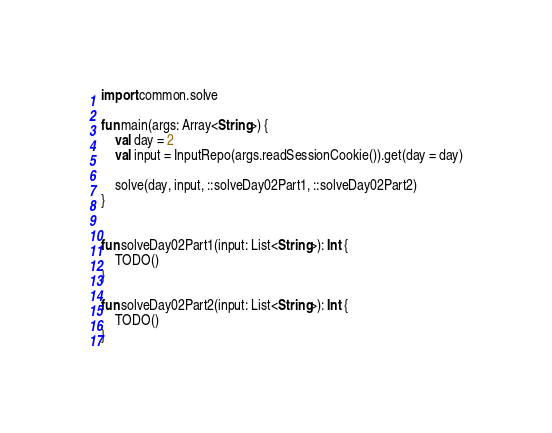<code> <loc_0><loc_0><loc_500><loc_500><_Kotlin_>import common.solve

fun main(args: Array<String>) {
    val day = 2
    val input = InputRepo(args.readSessionCookie()).get(day = day)

    solve(day, input, ::solveDay02Part1, ::solveDay02Part2)
}


fun solveDay02Part1(input: List<String>): Int {
    TODO()
}

fun solveDay02Part2(input: List<String>): Int {
    TODO()
}</code> 